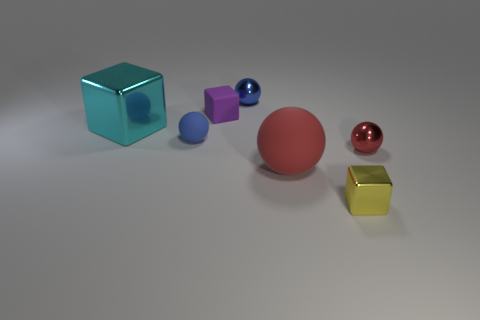What number of metallic spheres are right of the red metal sphere? 0 